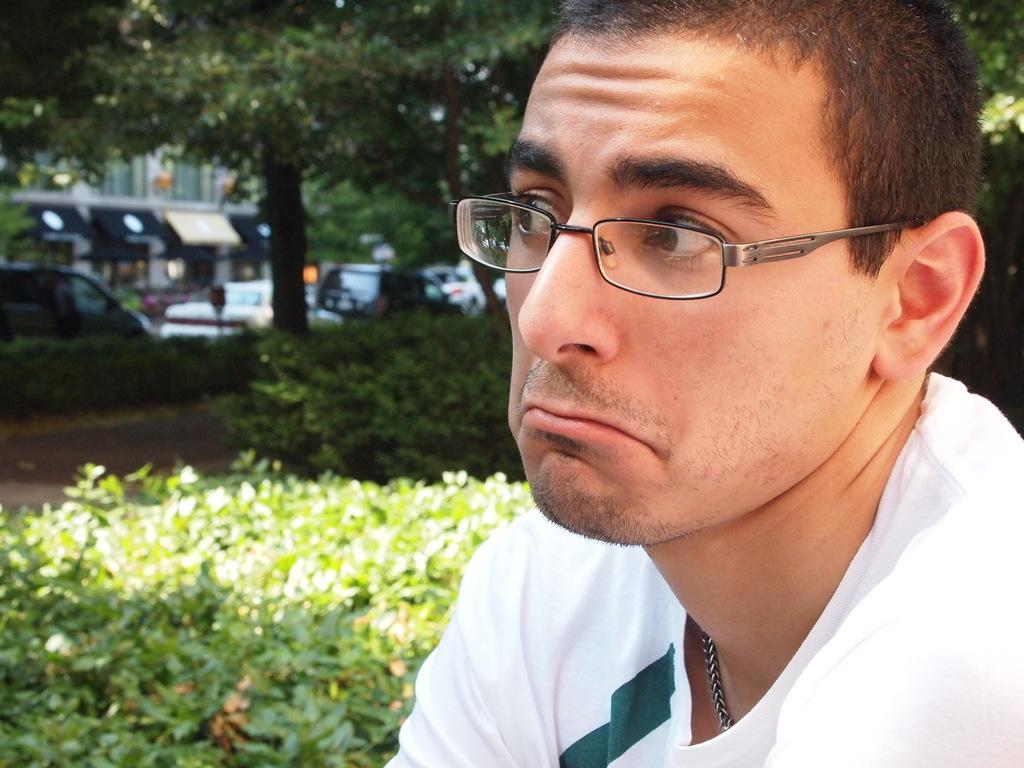Can you describe this image briefly? In this picture we can see the man wearing white t-shirt and looking on the left side. Behind there are some plants and trees. In the background we can see the cars on the road and buildings. 